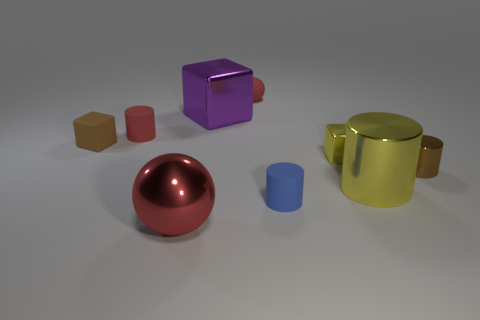Subtract all blue cylinders. How many cylinders are left? 3 Add 1 small cyan matte things. How many objects exist? 10 Subtract all purple cylinders. Subtract all yellow blocks. How many cylinders are left? 4 Subtract all balls. How many objects are left? 7 Add 4 red metal balls. How many red metal balls exist? 5 Subtract 1 brown cylinders. How many objects are left? 8 Subtract all big blue metal balls. Subtract all yellow things. How many objects are left? 7 Add 5 brown matte blocks. How many brown matte blocks are left? 6 